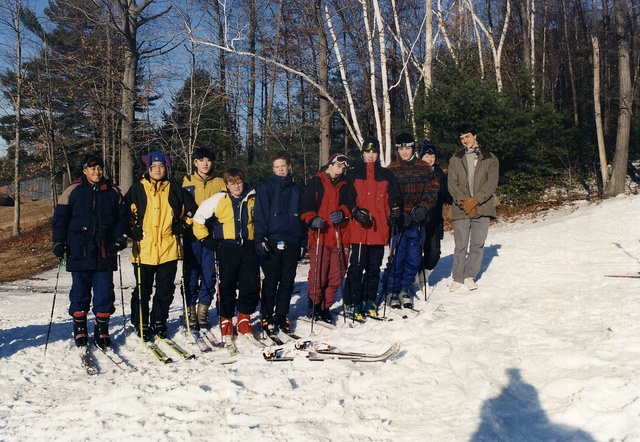Describe the objects in this image and their specific colors. I can see people in gray, black, and maroon tones, people in gray, black, khaki, tan, and orange tones, people in gray, black, brown, and maroon tones, people in gray, black, tan, lightgray, and gold tones, and people in gray, black, and tan tones in this image. 